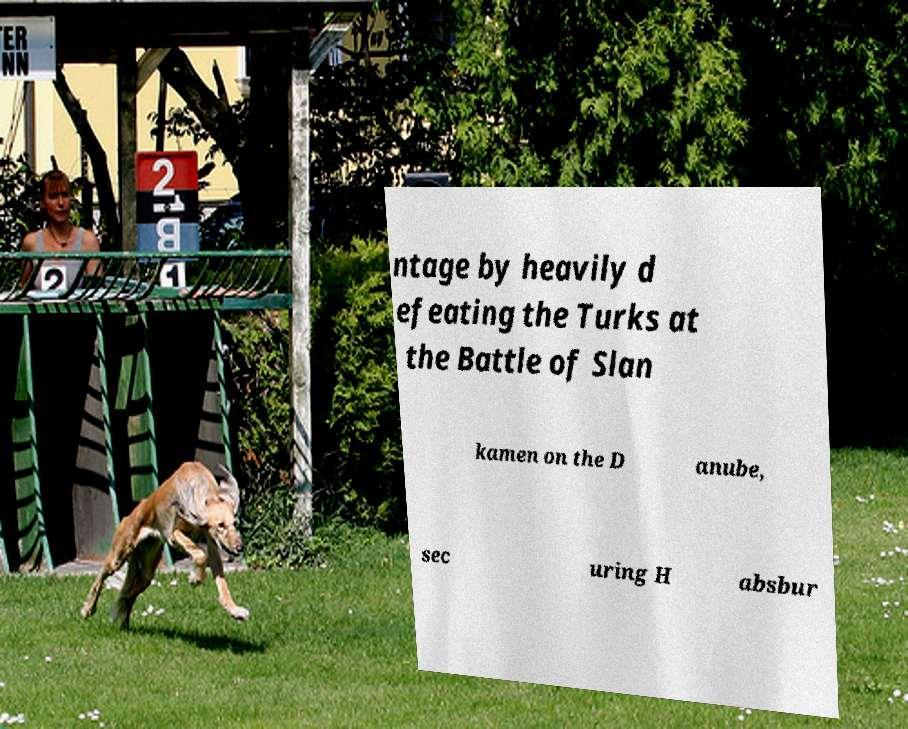Can you accurately transcribe the text from the provided image for me? ntage by heavily d efeating the Turks at the Battle of Slan kamen on the D anube, sec uring H absbur 